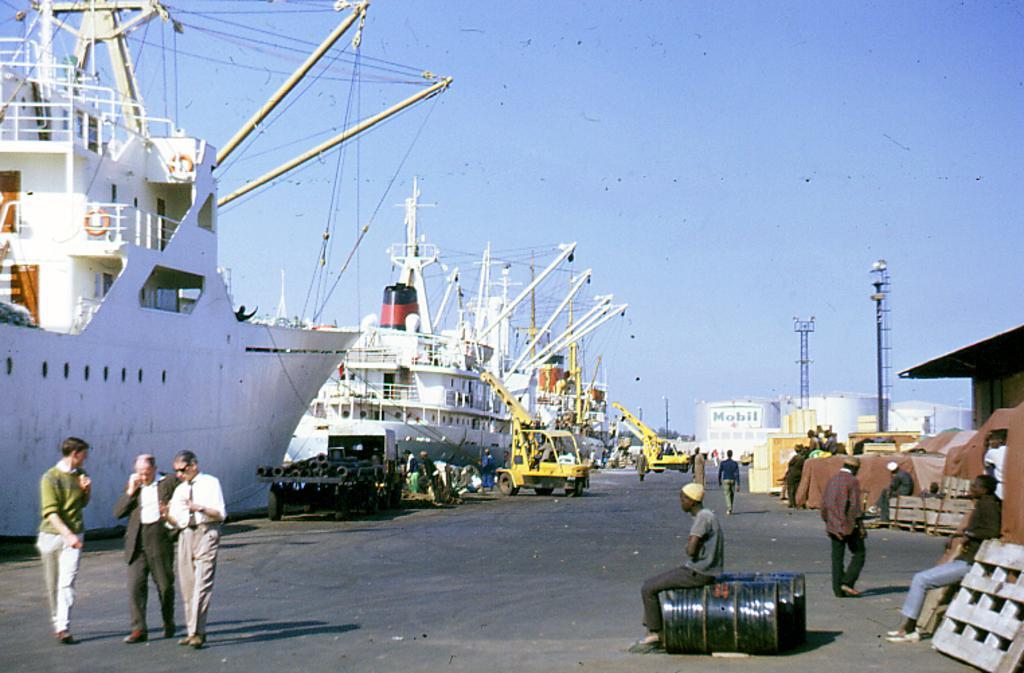Could you give a brief overview of what you see in this image? In the picture we can see a sea port with some ships which are white in color and poles and wires to it and beside to it, we can see a path and some people walking and some are sitting near the sheds, and we can also see a sky. 